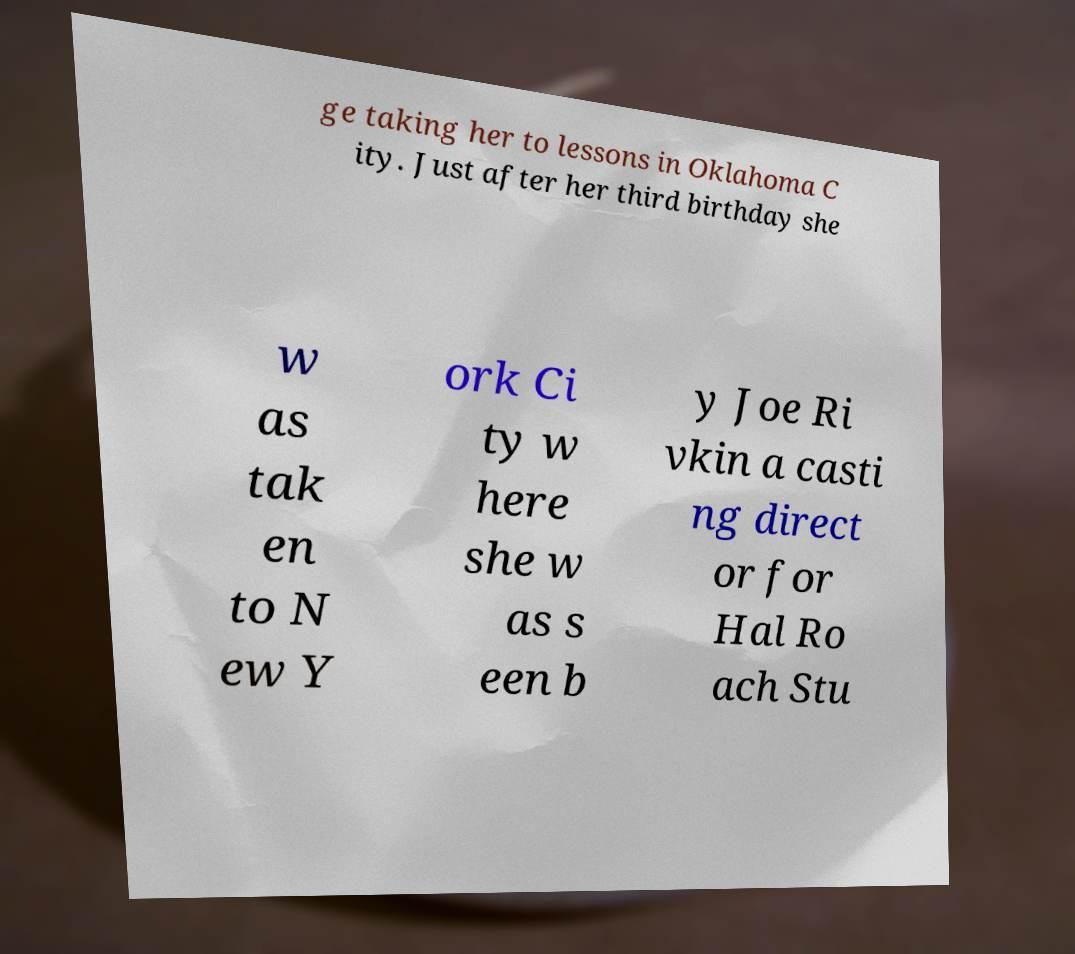I need the written content from this picture converted into text. Can you do that? ge taking her to lessons in Oklahoma C ity. Just after her third birthday she w as tak en to N ew Y ork Ci ty w here she w as s een b y Joe Ri vkin a casti ng direct or for Hal Ro ach Stu 